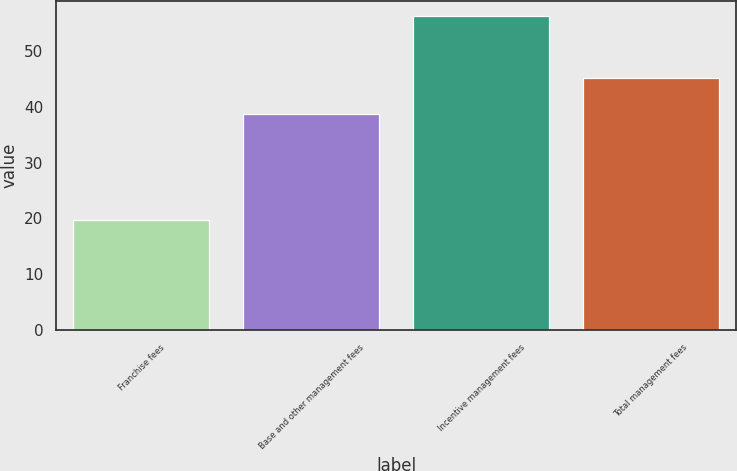Convert chart to OTSL. <chart><loc_0><loc_0><loc_500><loc_500><bar_chart><fcel>Franchise fees<fcel>Base and other management fees<fcel>Incentive management fees<fcel>Total management fees<nl><fcel>19.8<fcel>38.8<fcel>56.3<fcel>45.3<nl></chart> 